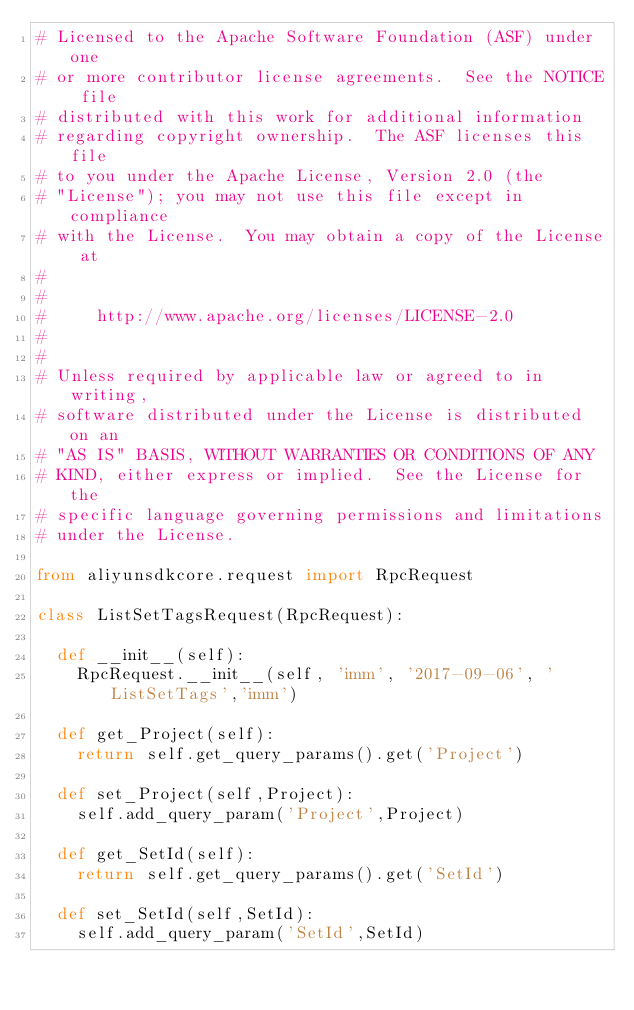<code> <loc_0><loc_0><loc_500><loc_500><_Python_># Licensed to the Apache Software Foundation (ASF) under one
# or more contributor license agreements.  See the NOTICE file
# distributed with this work for additional information
# regarding copyright ownership.  The ASF licenses this file
# to you under the Apache License, Version 2.0 (the
# "License"); you may not use this file except in compliance
# with the License.  You may obtain a copy of the License at
#
#
#     http://www.apache.org/licenses/LICENSE-2.0
#
#
# Unless required by applicable law or agreed to in writing,
# software distributed under the License is distributed on an
# "AS IS" BASIS, WITHOUT WARRANTIES OR CONDITIONS OF ANY
# KIND, either express or implied.  See the License for the
# specific language governing permissions and limitations
# under the License.

from aliyunsdkcore.request import RpcRequest

class ListSetTagsRequest(RpcRequest):

	def __init__(self):
		RpcRequest.__init__(self, 'imm', '2017-09-06', 'ListSetTags','imm')

	def get_Project(self):
		return self.get_query_params().get('Project')

	def set_Project(self,Project):
		self.add_query_param('Project',Project)

	def get_SetId(self):
		return self.get_query_params().get('SetId')

	def set_SetId(self,SetId):
		self.add_query_param('SetId',SetId)</code> 